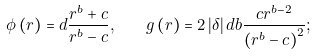Convert formula to latex. <formula><loc_0><loc_0><loc_500><loc_500>\phi \left ( r \right ) = d \frac { r ^ { b } + c } { r ^ { b } - c } , \quad g \left ( r \right ) = 2 \left | \delta \right | d b \frac { { c r ^ { b - 2 } } } { { \left ( { r ^ { b } - c } \right ) ^ { 2 } } } ;</formula> 